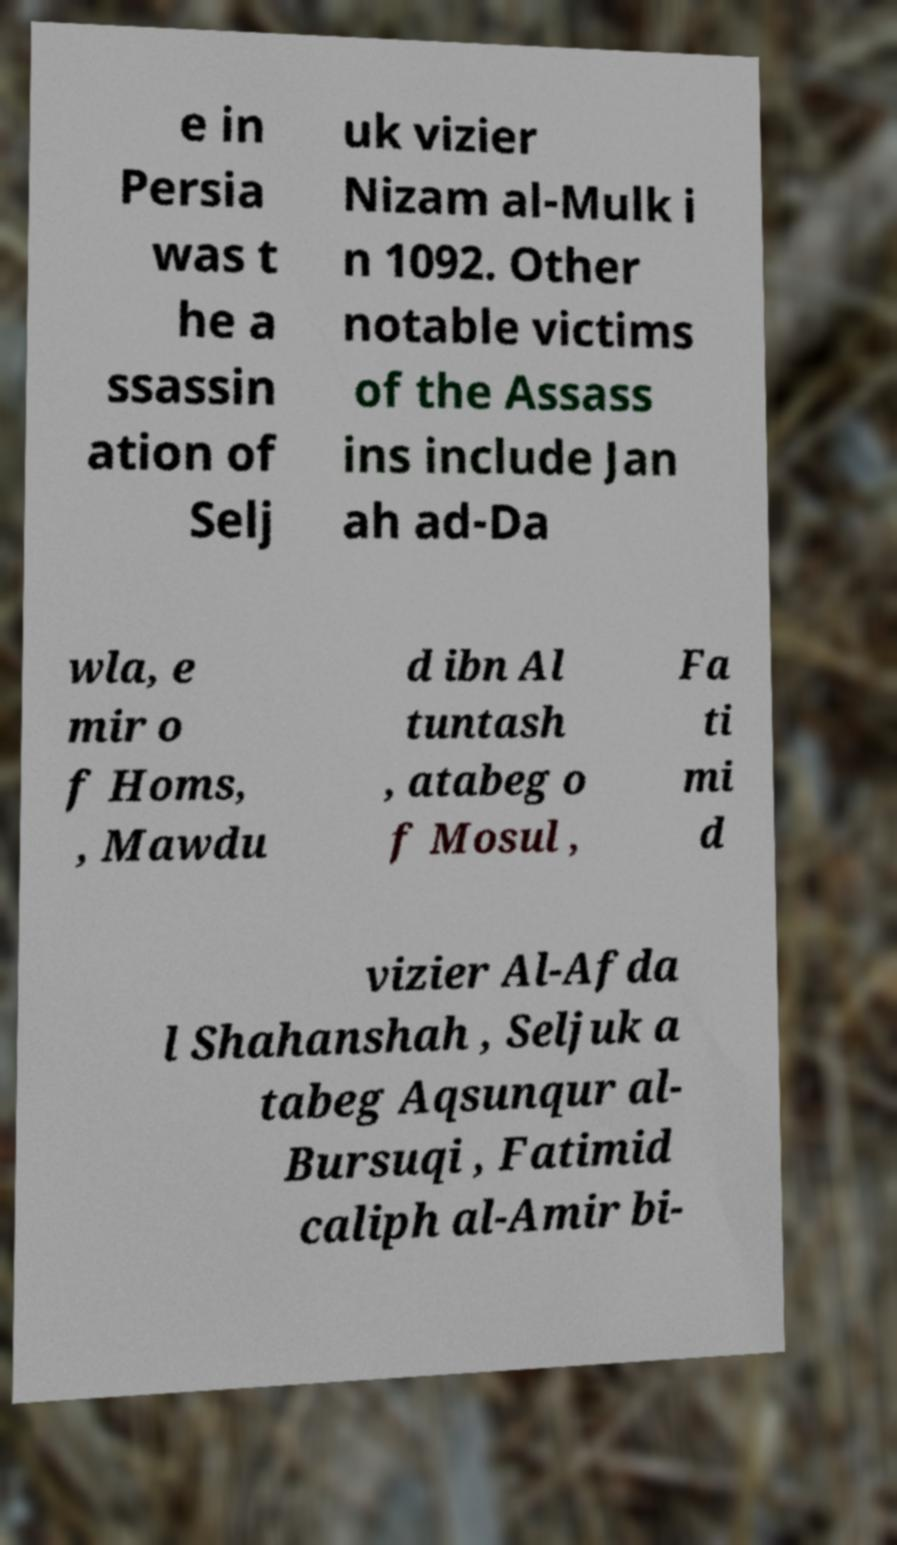Please read and relay the text visible in this image. What does it say? e in Persia was t he a ssassin ation of Selj uk vizier Nizam al-Mulk i n 1092. Other notable victims of the Assass ins include Jan ah ad-Da wla, e mir o f Homs, , Mawdu d ibn Al tuntash , atabeg o f Mosul , Fa ti mi d vizier Al-Afda l Shahanshah , Seljuk a tabeg Aqsunqur al- Bursuqi , Fatimid caliph al-Amir bi- 